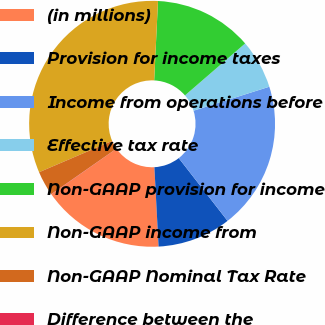Convert chart to OTSL. <chart><loc_0><loc_0><loc_500><loc_500><pie_chart><fcel>(in millions)<fcel>Provision for income taxes<fcel>Income from operations before<fcel>Effective tax rate<fcel>Non-GAAP provision for income<fcel>Non-GAAP income from<fcel>Non-GAAP Nominal Tax Rate<fcel>Difference between the<nl><fcel>16.12%<fcel>9.68%<fcel>19.36%<fcel>6.46%<fcel>12.9%<fcel>32.21%<fcel>3.25%<fcel>0.03%<nl></chart> 